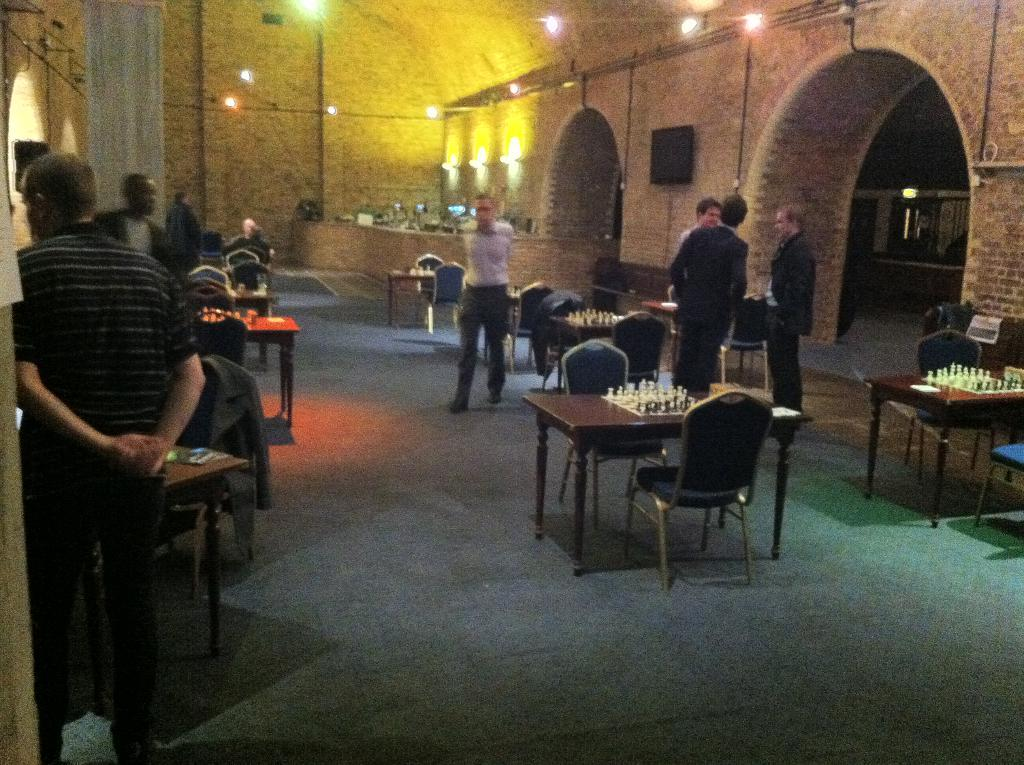What is happening in the image? There are people standing in the image. What can be seen on the table in the image? There is a table in the image, and it has a chess board on it. Are there any seating options visible in the image? Yes, there are chairs in the image. How many rabbits are playing chess on the table in the image? There are no rabbits present in the image, and they are not playing chess on the table. What type of authority figure is overseeing the chess game in the image? There is no authority figure present in the image, and no chess game is being overseen. 